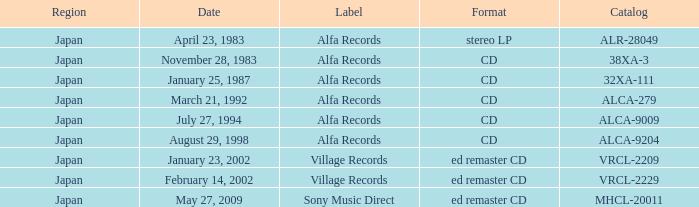Which part of the catalog corresponds to the 38xa-3 identifier? Japan. 